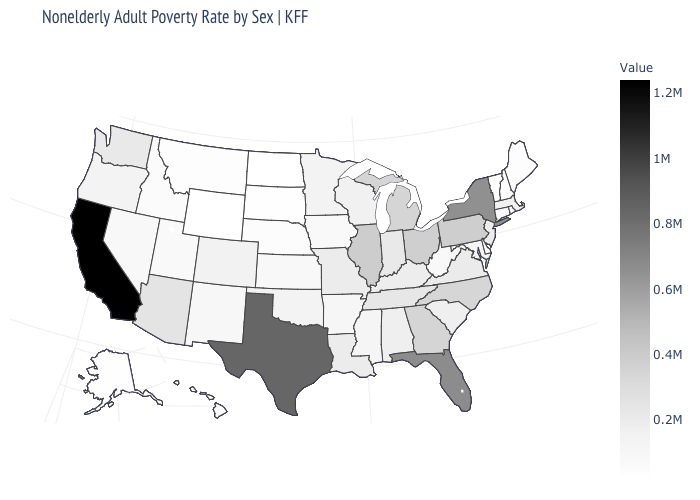Which states hav the highest value in the West?
Write a very short answer. California. Which states have the lowest value in the MidWest?
Concise answer only. North Dakota. 